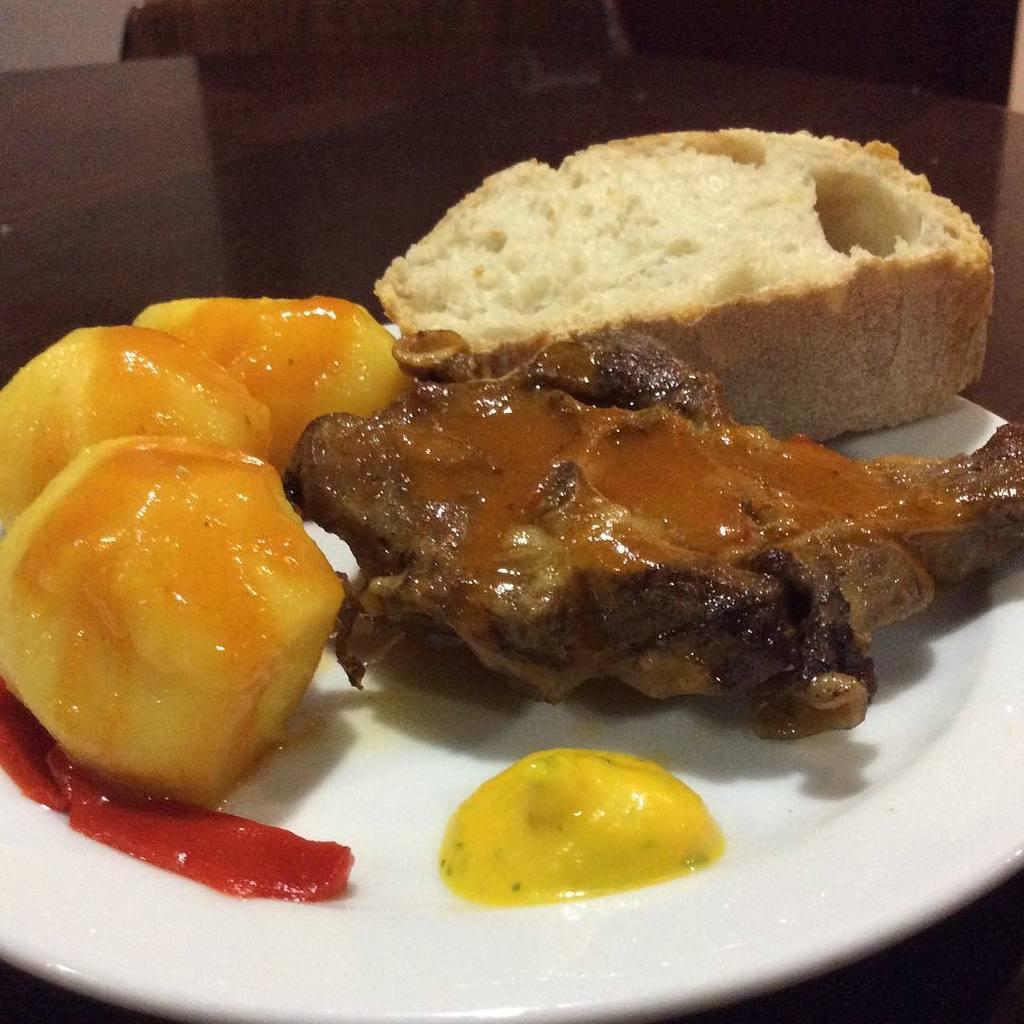Can you describe this image briefly? In this image I can see a plate , on the plate I can see food item. 